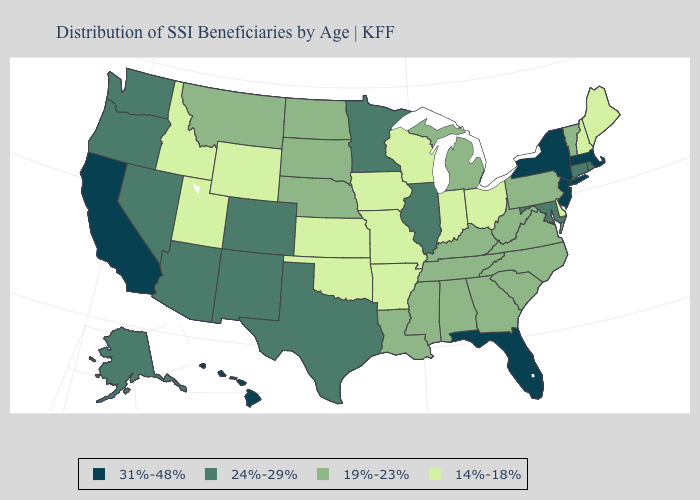Which states have the lowest value in the USA?
Answer briefly. Arkansas, Delaware, Idaho, Indiana, Iowa, Kansas, Maine, Missouri, New Hampshire, Ohio, Oklahoma, Utah, Wisconsin, Wyoming. Name the states that have a value in the range 19%-23%?
Concise answer only. Alabama, Georgia, Kentucky, Louisiana, Michigan, Mississippi, Montana, Nebraska, North Carolina, North Dakota, Pennsylvania, South Carolina, South Dakota, Tennessee, Vermont, Virginia, West Virginia. Name the states that have a value in the range 14%-18%?
Answer briefly. Arkansas, Delaware, Idaho, Indiana, Iowa, Kansas, Maine, Missouri, New Hampshire, Ohio, Oklahoma, Utah, Wisconsin, Wyoming. Does Pennsylvania have the highest value in the USA?
Answer briefly. No. Does Florida have the highest value in the USA?
Give a very brief answer. Yes. What is the value of Texas?
Be succinct. 24%-29%. What is the value of Ohio?
Give a very brief answer. 14%-18%. Name the states that have a value in the range 31%-48%?
Concise answer only. California, Florida, Hawaii, Massachusetts, New Jersey, New York. Among the states that border Delaware , which have the highest value?
Quick response, please. New Jersey. Does Kentucky have the lowest value in the USA?
Write a very short answer. No. Name the states that have a value in the range 14%-18%?
Short answer required. Arkansas, Delaware, Idaho, Indiana, Iowa, Kansas, Maine, Missouri, New Hampshire, Ohio, Oklahoma, Utah, Wisconsin, Wyoming. Does California have the highest value in the USA?
Write a very short answer. Yes. Is the legend a continuous bar?
Be succinct. No. What is the highest value in the USA?
Write a very short answer. 31%-48%. Which states have the lowest value in the Northeast?
Answer briefly. Maine, New Hampshire. 